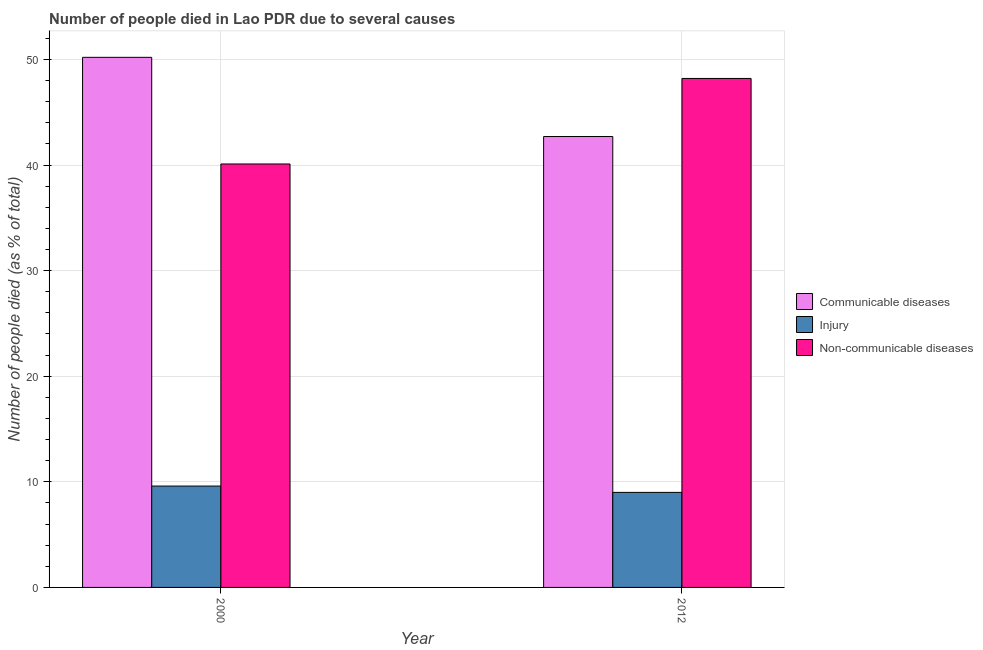How many different coloured bars are there?
Give a very brief answer. 3. Are the number of bars per tick equal to the number of legend labels?
Provide a short and direct response. Yes. Are the number of bars on each tick of the X-axis equal?
Provide a succinct answer. Yes. How many bars are there on the 2nd tick from the right?
Your answer should be compact. 3. What is the label of the 1st group of bars from the left?
Provide a succinct answer. 2000. What is the number of people who dies of non-communicable diseases in 2000?
Give a very brief answer. 40.1. Across all years, what is the maximum number of people who died of injury?
Offer a terse response. 9.6. Across all years, what is the minimum number of people who died of communicable diseases?
Make the answer very short. 42.7. In which year was the number of people who died of injury maximum?
Offer a very short reply. 2000. What is the total number of people who died of communicable diseases in the graph?
Offer a very short reply. 92.9. What is the difference between the number of people who dies of non-communicable diseases in 2000 and that in 2012?
Make the answer very short. -8.1. What is the average number of people who dies of non-communicable diseases per year?
Make the answer very short. 44.15. In how many years, is the number of people who died of communicable diseases greater than 24 %?
Provide a succinct answer. 2. What is the ratio of the number of people who dies of non-communicable diseases in 2000 to that in 2012?
Ensure brevity in your answer.  0.83. In how many years, is the number of people who dies of non-communicable diseases greater than the average number of people who dies of non-communicable diseases taken over all years?
Keep it short and to the point. 1. What does the 2nd bar from the left in 2012 represents?
Make the answer very short. Injury. What does the 2nd bar from the right in 2000 represents?
Ensure brevity in your answer.  Injury. Is it the case that in every year, the sum of the number of people who died of communicable diseases and number of people who died of injury is greater than the number of people who dies of non-communicable diseases?
Provide a short and direct response. Yes. How many bars are there?
Your answer should be very brief. 6. Are all the bars in the graph horizontal?
Provide a succinct answer. No. How many years are there in the graph?
Make the answer very short. 2. Are the values on the major ticks of Y-axis written in scientific E-notation?
Offer a terse response. No. Does the graph contain grids?
Your answer should be compact. Yes. Where does the legend appear in the graph?
Ensure brevity in your answer.  Center right. How many legend labels are there?
Give a very brief answer. 3. What is the title of the graph?
Your answer should be compact. Number of people died in Lao PDR due to several causes. Does "Renewable sources" appear as one of the legend labels in the graph?
Your answer should be very brief. No. What is the label or title of the Y-axis?
Provide a short and direct response. Number of people died (as % of total). What is the Number of people died (as % of total) in Communicable diseases in 2000?
Provide a succinct answer. 50.2. What is the Number of people died (as % of total) of Non-communicable diseases in 2000?
Your answer should be compact. 40.1. What is the Number of people died (as % of total) in Communicable diseases in 2012?
Provide a short and direct response. 42.7. What is the Number of people died (as % of total) in Injury in 2012?
Give a very brief answer. 9. What is the Number of people died (as % of total) of Non-communicable diseases in 2012?
Your answer should be very brief. 48.2. Across all years, what is the maximum Number of people died (as % of total) of Communicable diseases?
Offer a terse response. 50.2. Across all years, what is the maximum Number of people died (as % of total) of Non-communicable diseases?
Provide a short and direct response. 48.2. Across all years, what is the minimum Number of people died (as % of total) in Communicable diseases?
Give a very brief answer. 42.7. Across all years, what is the minimum Number of people died (as % of total) in Non-communicable diseases?
Your response must be concise. 40.1. What is the total Number of people died (as % of total) in Communicable diseases in the graph?
Keep it short and to the point. 92.9. What is the total Number of people died (as % of total) of Injury in the graph?
Make the answer very short. 18.6. What is the total Number of people died (as % of total) in Non-communicable diseases in the graph?
Provide a succinct answer. 88.3. What is the difference between the Number of people died (as % of total) in Communicable diseases in 2000 and that in 2012?
Make the answer very short. 7.5. What is the difference between the Number of people died (as % of total) in Injury in 2000 and that in 2012?
Offer a terse response. 0.6. What is the difference between the Number of people died (as % of total) of Non-communicable diseases in 2000 and that in 2012?
Your answer should be compact. -8.1. What is the difference between the Number of people died (as % of total) in Communicable diseases in 2000 and the Number of people died (as % of total) in Injury in 2012?
Your answer should be very brief. 41.2. What is the difference between the Number of people died (as % of total) in Communicable diseases in 2000 and the Number of people died (as % of total) in Non-communicable diseases in 2012?
Provide a short and direct response. 2. What is the difference between the Number of people died (as % of total) of Injury in 2000 and the Number of people died (as % of total) of Non-communicable diseases in 2012?
Your answer should be compact. -38.6. What is the average Number of people died (as % of total) in Communicable diseases per year?
Offer a very short reply. 46.45. What is the average Number of people died (as % of total) of Non-communicable diseases per year?
Give a very brief answer. 44.15. In the year 2000, what is the difference between the Number of people died (as % of total) in Communicable diseases and Number of people died (as % of total) in Injury?
Keep it short and to the point. 40.6. In the year 2000, what is the difference between the Number of people died (as % of total) of Injury and Number of people died (as % of total) of Non-communicable diseases?
Your answer should be very brief. -30.5. In the year 2012, what is the difference between the Number of people died (as % of total) of Communicable diseases and Number of people died (as % of total) of Injury?
Your response must be concise. 33.7. In the year 2012, what is the difference between the Number of people died (as % of total) of Communicable diseases and Number of people died (as % of total) of Non-communicable diseases?
Offer a terse response. -5.5. In the year 2012, what is the difference between the Number of people died (as % of total) in Injury and Number of people died (as % of total) in Non-communicable diseases?
Offer a very short reply. -39.2. What is the ratio of the Number of people died (as % of total) in Communicable diseases in 2000 to that in 2012?
Make the answer very short. 1.18. What is the ratio of the Number of people died (as % of total) of Injury in 2000 to that in 2012?
Ensure brevity in your answer.  1.07. What is the ratio of the Number of people died (as % of total) in Non-communicable diseases in 2000 to that in 2012?
Your answer should be compact. 0.83. What is the difference between the highest and the second highest Number of people died (as % of total) of Injury?
Offer a very short reply. 0.6. What is the difference between the highest and the second highest Number of people died (as % of total) of Non-communicable diseases?
Your answer should be compact. 8.1. What is the difference between the highest and the lowest Number of people died (as % of total) in Communicable diseases?
Keep it short and to the point. 7.5. What is the difference between the highest and the lowest Number of people died (as % of total) in Non-communicable diseases?
Make the answer very short. 8.1. 